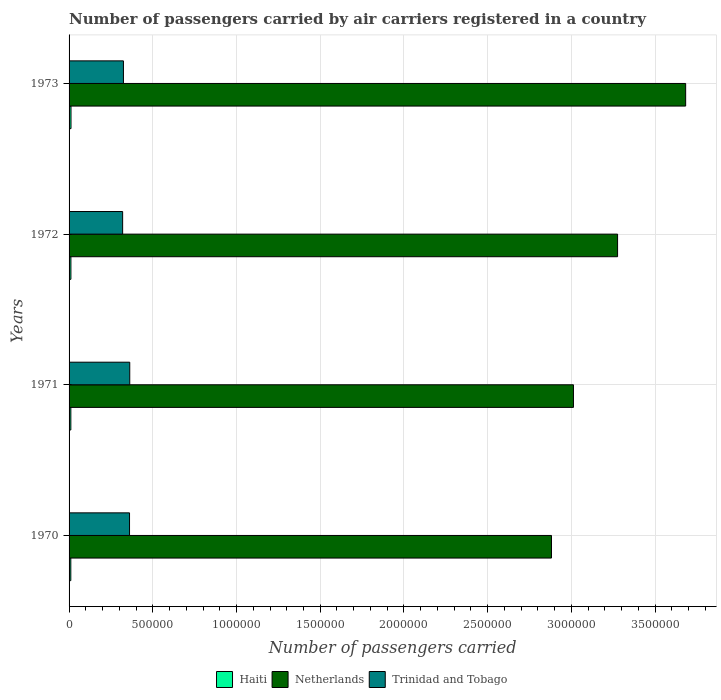Are the number of bars per tick equal to the number of legend labels?
Make the answer very short. Yes. How many bars are there on the 3rd tick from the top?
Make the answer very short. 3. How many bars are there on the 2nd tick from the bottom?
Your response must be concise. 3. What is the label of the 2nd group of bars from the top?
Your answer should be very brief. 1972. In how many cases, is the number of bars for a given year not equal to the number of legend labels?
Provide a succinct answer. 0. What is the number of passengers carried by air carriers in Netherlands in 1971?
Provide a succinct answer. 3.01e+06. Across all years, what is the maximum number of passengers carried by air carriers in Haiti?
Offer a terse response. 1.15e+04. Across all years, what is the minimum number of passengers carried by air carriers in Netherlands?
Your answer should be very brief. 2.88e+06. What is the total number of passengers carried by air carriers in Netherlands in the graph?
Ensure brevity in your answer.  1.29e+07. What is the difference between the number of passengers carried by air carriers in Trinidad and Tobago in 1971 and that in 1972?
Keep it short and to the point. 4.25e+04. What is the difference between the number of passengers carried by air carriers in Netherlands in 1971 and the number of passengers carried by air carriers in Trinidad and Tobago in 1970?
Your answer should be compact. 2.65e+06. What is the average number of passengers carried by air carriers in Netherlands per year?
Your answer should be compact. 3.21e+06. In the year 1970, what is the difference between the number of passengers carried by air carriers in Haiti and number of passengers carried by air carriers in Netherlands?
Give a very brief answer. -2.87e+06. In how many years, is the number of passengers carried by air carriers in Haiti greater than 2000000 ?
Provide a short and direct response. 0. What is the ratio of the number of passengers carried by air carriers in Trinidad and Tobago in 1971 to that in 1972?
Keep it short and to the point. 1.13. Is the difference between the number of passengers carried by air carriers in Haiti in 1971 and 1973 greater than the difference between the number of passengers carried by air carriers in Netherlands in 1971 and 1973?
Make the answer very short. Yes. What is the difference between the highest and the second highest number of passengers carried by air carriers in Netherlands?
Offer a terse response. 4.07e+05. What is the difference between the highest and the lowest number of passengers carried by air carriers in Trinidad and Tobago?
Provide a succinct answer. 4.25e+04. In how many years, is the number of passengers carried by air carriers in Haiti greater than the average number of passengers carried by air carriers in Haiti taken over all years?
Provide a short and direct response. 2. What does the 1st bar from the top in 1973 represents?
Provide a short and direct response. Trinidad and Tobago. What does the 1st bar from the bottom in 1973 represents?
Give a very brief answer. Haiti. How many bars are there?
Offer a very short reply. 12. How many years are there in the graph?
Provide a short and direct response. 4. What is the difference between two consecutive major ticks on the X-axis?
Provide a short and direct response. 5.00e+05. Are the values on the major ticks of X-axis written in scientific E-notation?
Offer a terse response. No. Does the graph contain any zero values?
Provide a short and direct response. No. Where does the legend appear in the graph?
Keep it short and to the point. Bottom center. How many legend labels are there?
Provide a short and direct response. 3. What is the title of the graph?
Your response must be concise. Number of passengers carried by air carriers registered in a country. What is the label or title of the X-axis?
Keep it short and to the point. Number of passengers carried. What is the label or title of the Y-axis?
Your answer should be compact. Years. What is the Number of passengers carried of Haiti in 1970?
Give a very brief answer. 1.04e+04. What is the Number of passengers carried in Netherlands in 1970?
Your answer should be compact. 2.88e+06. What is the Number of passengers carried in Trinidad and Tobago in 1970?
Provide a short and direct response. 3.61e+05. What is the Number of passengers carried in Haiti in 1971?
Make the answer very short. 1.06e+04. What is the Number of passengers carried in Netherlands in 1971?
Offer a terse response. 3.01e+06. What is the Number of passengers carried of Trinidad and Tobago in 1971?
Make the answer very short. 3.62e+05. What is the Number of passengers carried of Haiti in 1972?
Offer a very short reply. 1.10e+04. What is the Number of passengers carried in Netherlands in 1972?
Give a very brief answer. 3.28e+06. What is the Number of passengers carried in Trinidad and Tobago in 1972?
Ensure brevity in your answer.  3.20e+05. What is the Number of passengers carried of Haiti in 1973?
Ensure brevity in your answer.  1.15e+04. What is the Number of passengers carried in Netherlands in 1973?
Offer a terse response. 3.68e+06. What is the Number of passengers carried of Trinidad and Tobago in 1973?
Provide a succinct answer. 3.25e+05. Across all years, what is the maximum Number of passengers carried in Haiti?
Make the answer very short. 1.15e+04. Across all years, what is the maximum Number of passengers carried of Netherlands?
Provide a short and direct response. 3.68e+06. Across all years, what is the maximum Number of passengers carried in Trinidad and Tobago?
Offer a very short reply. 3.62e+05. Across all years, what is the minimum Number of passengers carried of Haiti?
Make the answer very short. 1.04e+04. Across all years, what is the minimum Number of passengers carried of Netherlands?
Give a very brief answer. 2.88e+06. Across all years, what is the minimum Number of passengers carried of Trinidad and Tobago?
Your response must be concise. 3.20e+05. What is the total Number of passengers carried in Haiti in the graph?
Your answer should be compact. 4.35e+04. What is the total Number of passengers carried in Netherlands in the graph?
Your response must be concise. 1.29e+07. What is the total Number of passengers carried in Trinidad and Tobago in the graph?
Offer a very short reply. 1.37e+06. What is the difference between the Number of passengers carried in Haiti in 1970 and that in 1971?
Ensure brevity in your answer.  -200. What is the difference between the Number of passengers carried in Netherlands in 1970 and that in 1971?
Keep it short and to the point. -1.31e+05. What is the difference between the Number of passengers carried of Trinidad and Tobago in 1970 and that in 1971?
Ensure brevity in your answer.  -1300. What is the difference between the Number of passengers carried of Haiti in 1970 and that in 1972?
Offer a terse response. -600. What is the difference between the Number of passengers carried of Netherlands in 1970 and that in 1972?
Provide a succinct answer. -3.95e+05. What is the difference between the Number of passengers carried in Trinidad and Tobago in 1970 and that in 1972?
Ensure brevity in your answer.  4.12e+04. What is the difference between the Number of passengers carried of Haiti in 1970 and that in 1973?
Provide a succinct answer. -1100. What is the difference between the Number of passengers carried of Netherlands in 1970 and that in 1973?
Keep it short and to the point. -8.01e+05. What is the difference between the Number of passengers carried of Trinidad and Tobago in 1970 and that in 1973?
Your answer should be very brief. 3.64e+04. What is the difference between the Number of passengers carried in Haiti in 1971 and that in 1972?
Provide a succinct answer. -400. What is the difference between the Number of passengers carried in Netherlands in 1971 and that in 1972?
Give a very brief answer. -2.64e+05. What is the difference between the Number of passengers carried in Trinidad and Tobago in 1971 and that in 1972?
Give a very brief answer. 4.25e+04. What is the difference between the Number of passengers carried in Haiti in 1971 and that in 1973?
Make the answer very short. -900. What is the difference between the Number of passengers carried of Netherlands in 1971 and that in 1973?
Provide a short and direct response. -6.70e+05. What is the difference between the Number of passengers carried of Trinidad and Tobago in 1971 and that in 1973?
Provide a short and direct response. 3.77e+04. What is the difference between the Number of passengers carried of Haiti in 1972 and that in 1973?
Your answer should be compact. -500. What is the difference between the Number of passengers carried in Netherlands in 1972 and that in 1973?
Provide a succinct answer. -4.07e+05. What is the difference between the Number of passengers carried in Trinidad and Tobago in 1972 and that in 1973?
Your response must be concise. -4800. What is the difference between the Number of passengers carried in Haiti in 1970 and the Number of passengers carried in Netherlands in 1971?
Provide a short and direct response. -3.00e+06. What is the difference between the Number of passengers carried in Haiti in 1970 and the Number of passengers carried in Trinidad and Tobago in 1971?
Ensure brevity in your answer.  -3.52e+05. What is the difference between the Number of passengers carried in Netherlands in 1970 and the Number of passengers carried in Trinidad and Tobago in 1971?
Provide a short and direct response. 2.52e+06. What is the difference between the Number of passengers carried of Haiti in 1970 and the Number of passengers carried of Netherlands in 1972?
Offer a very short reply. -3.27e+06. What is the difference between the Number of passengers carried of Haiti in 1970 and the Number of passengers carried of Trinidad and Tobago in 1972?
Your answer should be compact. -3.10e+05. What is the difference between the Number of passengers carried in Netherlands in 1970 and the Number of passengers carried in Trinidad and Tobago in 1972?
Make the answer very short. 2.56e+06. What is the difference between the Number of passengers carried in Haiti in 1970 and the Number of passengers carried in Netherlands in 1973?
Offer a terse response. -3.67e+06. What is the difference between the Number of passengers carried of Haiti in 1970 and the Number of passengers carried of Trinidad and Tobago in 1973?
Keep it short and to the point. -3.14e+05. What is the difference between the Number of passengers carried of Netherlands in 1970 and the Number of passengers carried of Trinidad and Tobago in 1973?
Your answer should be very brief. 2.56e+06. What is the difference between the Number of passengers carried in Haiti in 1971 and the Number of passengers carried in Netherlands in 1972?
Offer a very short reply. -3.27e+06. What is the difference between the Number of passengers carried of Haiti in 1971 and the Number of passengers carried of Trinidad and Tobago in 1972?
Ensure brevity in your answer.  -3.09e+05. What is the difference between the Number of passengers carried of Netherlands in 1971 and the Number of passengers carried of Trinidad and Tobago in 1972?
Offer a terse response. 2.69e+06. What is the difference between the Number of passengers carried of Haiti in 1971 and the Number of passengers carried of Netherlands in 1973?
Offer a very short reply. -3.67e+06. What is the difference between the Number of passengers carried in Haiti in 1971 and the Number of passengers carried in Trinidad and Tobago in 1973?
Provide a short and direct response. -3.14e+05. What is the difference between the Number of passengers carried in Netherlands in 1971 and the Number of passengers carried in Trinidad and Tobago in 1973?
Offer a terse response. 2.69e+06. What is the difference between the Number of passengers carried of Haiti in 1972 and the Number of passengers carried of Netherlands in 1973?
Your response must be concise. -3.67e+06. What is the difference between the Number of passengers carried of Haiti in 1972 and the Number of passengers carried of Trinidad and Tobago in 1973?
Provide a short and direct response. -3.14e+05. What is the difference between the Number of passengers carried in Netherlands in 1972 and the Number of passengers carried in Trinidad and Tobago in 1973?
Offer a very short reply. 2.95e+06. What is the average Number of passengers carried in Haiti per year?
Your response must be concise. 1.09e+04. What is the average Number of passengers carried of Netherlands per year?
Provide a short and direct response. 3.21e+06. What is the average Number of passengers carried in Trinidad and Tobago per year?
Your answer should be compact. 3.42e+05. In the year 1970, what is the difference between the Number of passengers carried in Haiti and Number of passengers carried in Netherlands?
Offer a very short reply. -2.87e+06. In the year 1970, what is the difference between the Number of passengers carried of Haiti and Number of passengers carried of Trinidad and Tobago?
Offer a very short reply. -3.51e+05. In the year 1970, what is the difference between the Number of passengers carried in Netherlands and Number of passengers carried in Trinidad and Tobago?
Provide a short and direct response. 2.52e+06. In the year 1971, what is the difference between the Number of passengers carried of Haiti and Number of passengers carried of Netherlands?
Offer a terse response. -3.00e+06. In the year 1971, what is the difference between the Number of passengers carried of Haiti and Number of passengers carried of Trinidad and Tobago?
Your response must be concise. -3.52e+05. In the year 1971, what is the difference between the Number of passengers carried of Netherlands and Number of passengers carried of Trinidad and Tobago?
Provide a succinct answer. 2.65e+06. In the year 1972, what is the difference between the Number of passengers carried of Haiti and Number of passengers carried of Netherlands?
Provide a short and direct response. -3.26e+06. In the year 1972, what is the difference between the Number of passengers carried in Haiti and Number of passengers carried in Trinidad and Tobago?
Provide a succinct answer. -3.09e+05. In the year 1972, what is the difference between the Number of passengers carried of Netherlands and Number of passengers carried of Trinidad and Tobago?
Keep it short and to the point. 2.96e+06. In the year 1973, what is the difference between the Number of passengers carried in Haiti and Number of passengers carried in Netherlands?
Make the answer very short. -3.67e+06. In the year 1973, what is the difference between the Number of passengers carried of Haiti and Number of passengers carried of Trinidad and Tobago?
Give a very brief answer. -3.13e+05. In the year 1973, what is the difference between the Number of passengers carried of Netherlands and Number of passengers carried of Trinidad and Tobago?
Offer a very short reply. 3.36e+06. What is the ratio of the Number of passengers carried in Haiti in 1970 to that in 1971?
Make the answer very short. 0.98. What is the ratio of the Number of passengers carried of Netherlands in 1970 to that in 1971?
Your answer should be compact. 0.96. What is the ratio of the Number of passengers carried in Haiti in 1970 to that in 1972?
Keep it short and to the point. 0.95. What is the ratio of the Number of passengers carried of Netherlands in 1970 to that in 1972?
Your answer should be compact. 0.88. What is the ratio of the Number of passengers carried in Trinidad and Tobago in 1970 to that in 1972?
Your answer should be very brief. 1.13. What is the ratio of the Number of passengers carried in Haiti in 1970 to that in 1973?
Ensure brevity in your answer.  0.9. What is the ratio of the Number of passengers carried of Netherlands in 1970 to that in 1973?
Your response must be concise. 0.78. What is the ratio of the Number of passengers carried of Trinidad and Tobago in 1970 to that in 1973?
Offer a terse response. 1.11. What is the ratio of the Number of passengers carried of Haiti in 1971 to that in 1972?
Your answer should be very brief. 0.96. What is the ratio of the Number of passengers carried of Netherlands in 1971 to that in 1972?
Provide a succinct answer. 0.92. What is the ratio of the Number of passengers carried of Trinidad and Tobago in 1971 to that in 1972?
Make the answer very short. 1.13. What is the ratio of the Number of passengers carried in Haiti in 1971 to that in 1973?
Keep it short and to the point. 0.92. What is the ratio of the Number of passengers carried in Netherlands in 1971 to that in 1973?
Give a very brief answer. 0.82. What is the ratio of the Number of passengers carried in Trinidad and Tobago in 1971 to that in 1973?
Keep it short and to the point. 1.12. What is the ratio of the Number of passengers carried of Haiti in 1972 to that in 1973?
Provide a short and direct response. 0.96. What is the ratio of the Number of passengers carried of Netherlands in 1972 to that in 1973?
Give a very brief answer. 0.89. What is the ratio of the Number of passengers carried in Trinidad and Tobago in 1972 to that in 1973?
Your response must be concise. 0.99. What is the difference between the highest and the second highest Number of passengers carried in Netherlands?
Your answer should be compact. 4.07e+05. What is the difference between the highest and the second highest Number of passengers carried of Trinidad and Tobago?
Make the answer very short. 1300. What is the difference between the highest and the lowest Number of passengers carried in Haiti?
Ensure brevity in your answer.  1100. What is the difference between the highest and the lowest Number of passengers carried of Netherlands?
Give a very brief answer. 8.01e+05. What is the difference between the highest and the lowest Number of passengers carried of Trinidad and Tobago?
Offer a terse response. 4.25e+04. 